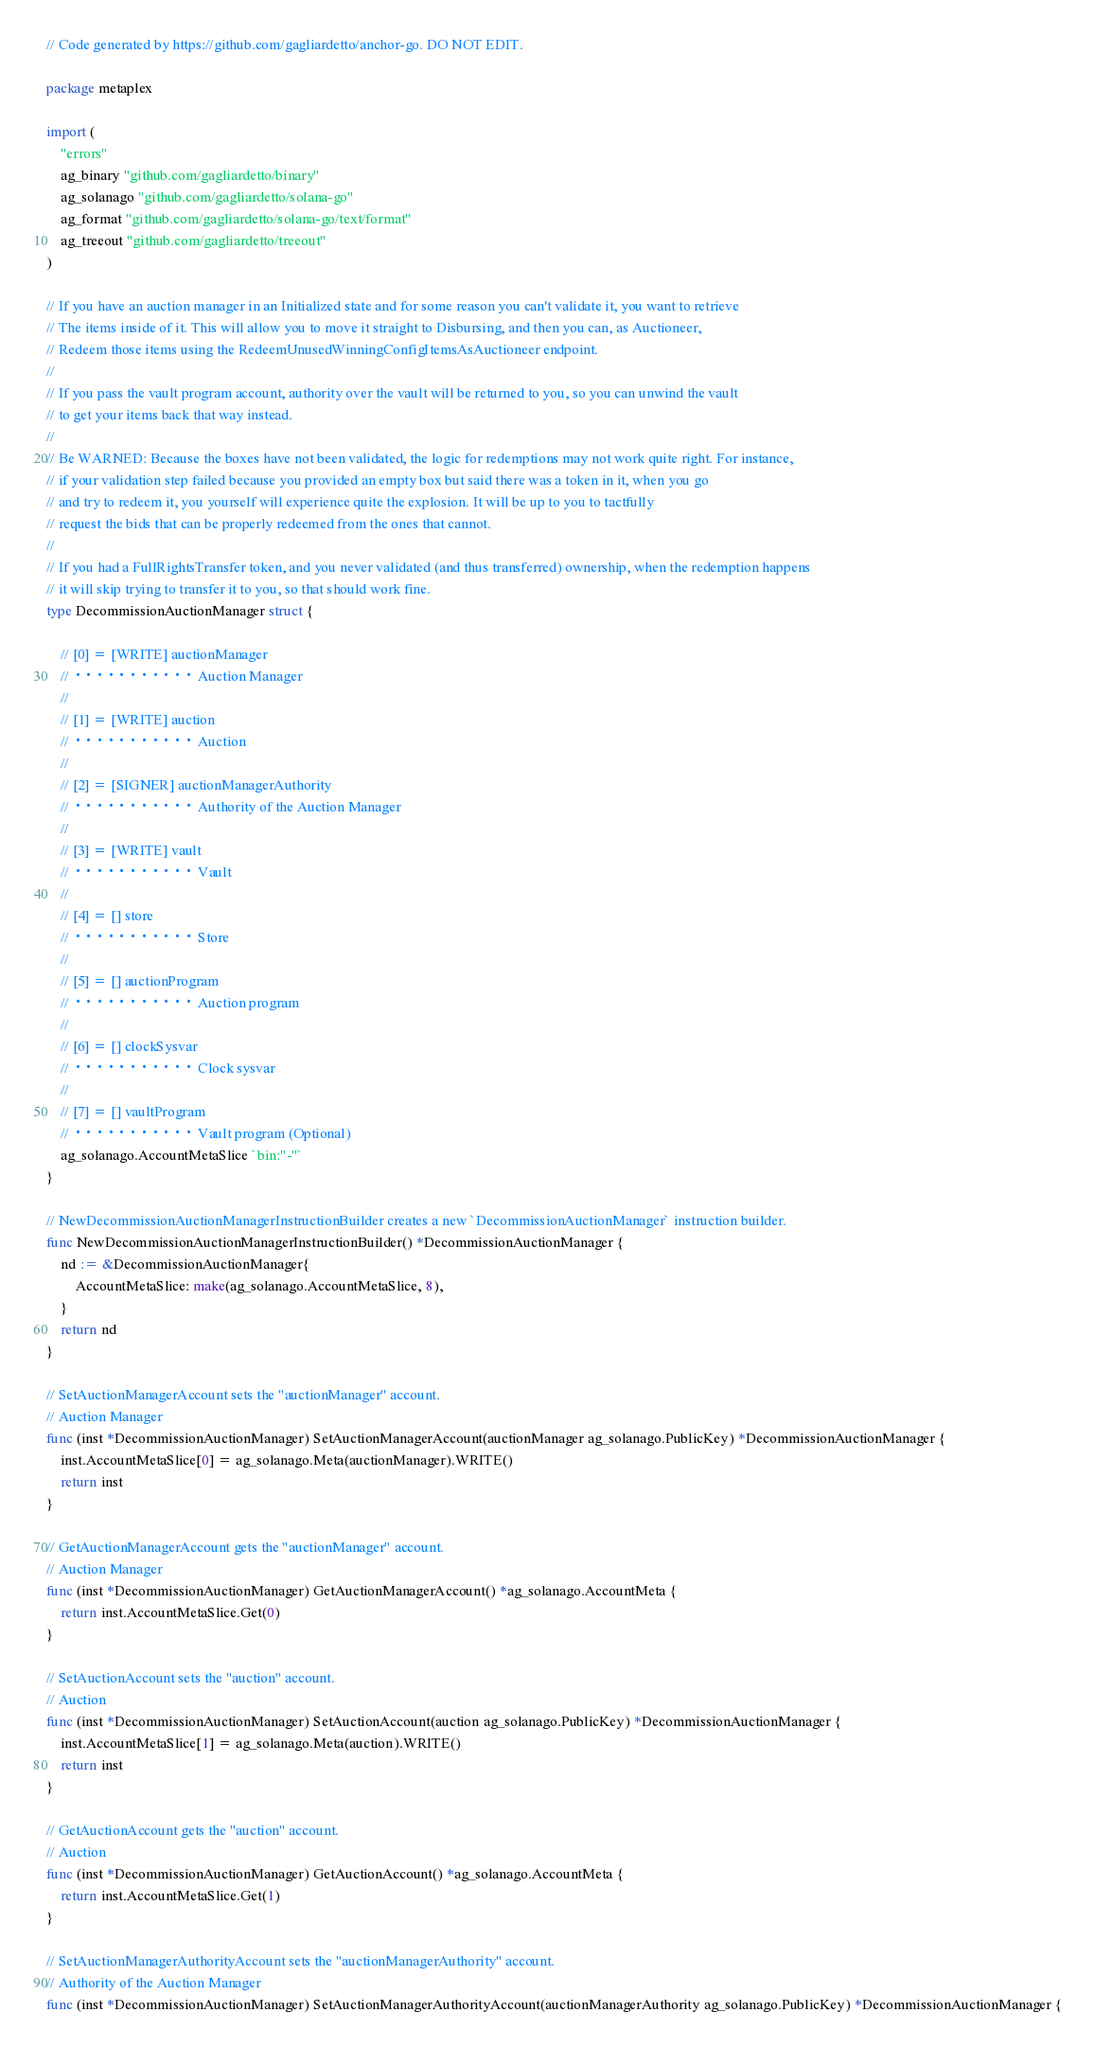Convert code to text. <code><loc_0><loc_0><loc_500><loc_500><_Go_>// Code generated by https://github.com/gagliardetto/anchor-go. DO NOT EDIT.

package metaplex

import (
	"errors"
	ag_binary "github.com/gagliardetto/binary"
	ag_solanago "github.com/gagliardetto/solana-go"
	ag_format "github.com/gagliardetto/solana-go/text/format"
	ag_treeout "github.com/gagliardetto/treeout"
)

// If you have an auction manager in an Initialized state and for some reason you can't validate it, you want to retrieve
// The items inside of it. This will allow you to move it straight to Disbursing, and then you can, as Auctioneer,
// Redeem those items using the RedeemUnusedWinningConfigItemsAsAuctioneer endpoint.
//
// If you pass the vault program account, authority over the vault will be returned to you, so you can unwind the vault
// to get your items back that way instead.
//
// Be WARNED: Because the boxes have not been validated, the logic for redemptions may not work quite right. For instance,
// if your validation step failed because you provided an empty box but said there was a token in it, when you go
// and try to redeem it, you yourself will experience quite the explosion. It will be up to you to tactfully
// request the bids that can be properly redeemed from the ones that cannot.
//
// If you had a FullRightsTransfer token, and you never validated (and thus transferred) ownership, when the redemption happens
// it will skip trying to transfer it to you, so that should work fine.
type DecommissionAuctionManager struct {

	// [0] = [WRITE] auctionManager
	// ··········· Auction Manager
	//
	// [1] = [WRITE] auction
	// ··········· Auction
	//
	// [2] = [SIGNER] auctionManagerAuthority
	// ··········· Authority of the Auction Manager
	//
	// [3] = [WRITE] vault
	// ··········· Vault
	//
	// [4] = [] store
	// ··········· Store
	//
	// [5] = [] auctionProgram
	// ··········· Auction program
	//
	// [6] = [] clockSysvar
	// ··········· Clock sysvar
	//
	// [7] = [] vaultProgram
	// ··········· Vault program (Optional)
	ag_solanago.AccountMetaSlice `bin:"-"`
}

// NewDecommissionAuctionManagerInstructionBuilder creates a new `DecommissionAuctionManager` instruction builder.
func NewDecommissionAuctionManagerInstructionBuilder() *DecommissionAuctionManager {
	nd := &DecommissionAuctionManager{
		AccountMetaSlice: make(ag_solanago.AccountMetaSlice, 8),
	}
	return nd
}

// SetAuctionManagerAccount sets the "auctionManager" account.
// Auction Manager
func (inst *DecommissionAuctionManager) SetAuctionManagerAccount(auctionManager ag_solanago.PublicKey) *DecommissionAuctionManager {
	inst.AccountMetaSlice[0] = ag_solanago.Meta(auctionManager).WRITE()
	return inst
}

// GetAuctionManagerAccount gets the "auctionManager" account.
// Auction Manager
func (inst *DecommissionAuctionManager) GetAuctionManagerAccount() *ag_solanago.AccountMeta {
	return inst.AccountMetaSlice.Get(0)
}

// SetAuctionAccount sets the "auction" account.
// Auction
func (inst *DecommissionAuctionManager) SetAuctionAccount(auction ag_solanago.PublicKey) *DecommissionAuctionManager {
	inst.AccountMetaSlice[1] = ag_solanago.Meta(auction).WRITE()
	return inst
}

// GetAuctionAccount gets the "auction" account.
// Auction
func (inst *DecommissionAuctionManager) GetAuctionAccount() *ag_solanago.AccountMeta {
	return inst.AccountMetaSlice.Get(1)
}

// SetAuctionManagerAuthorityAccount sets the "auctionManagerAuthority" account.
// Authority of the Auction Manager
func (inst *DecommissionAuctionManager) SetAuctionManagerAuthorityAccount(auctionManagerAuthority ag_solanago.PublicKey) *DecommissionAuctionManager {</code> 